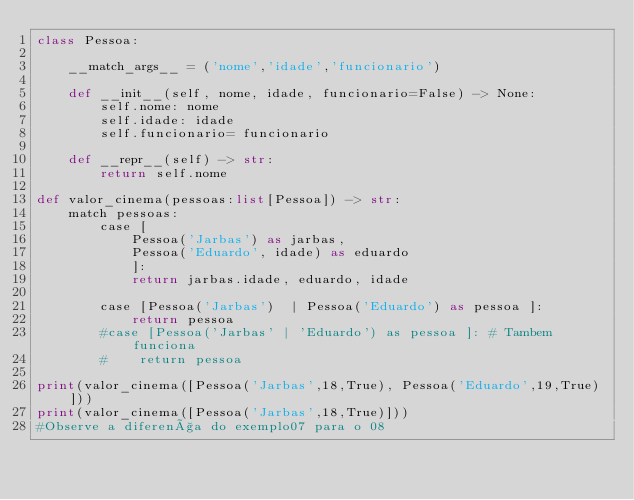<code> <loc_0><loc_0><loc_500><loc_500><_Python_>class Pessoa:

    __match_args__ = ('nome','idade','funcionario')

    def __init__(self, nome, idade, funcionario=False) -> None:            
        self.nome: nome
        self.idade: idade
        self.funcionario= funcionario

    def __repr__(self) -> str:
        return self.nome

def valor_cinema(pessoas:list[Pessoa]) -> str:
    match pessoas:
        case [
            Pessoa('Jarbas') as jarbas, 
            Pessoa('Eduardo', idade) as eduardo
            ]:
            return jarbas.idade, eduardo, idade

        case [Pessoa('Jarbas')  | Pessoa('Eduardo') as pessoa ]:
            return pessoa
        #case [Pessoa('Jarbas' | 'Eduardo') as pessoa ]: # Tambem funciona
        #    return pessoa

print(valor_cinema([Pessoa('Jarbas',18,True), Pessoa('Eduardo',19,True)]))
print(valor_cinema([Pessoa('Jarbas',18,True)]))
#Observe a diferença do exemplo07 para o 08</code> 